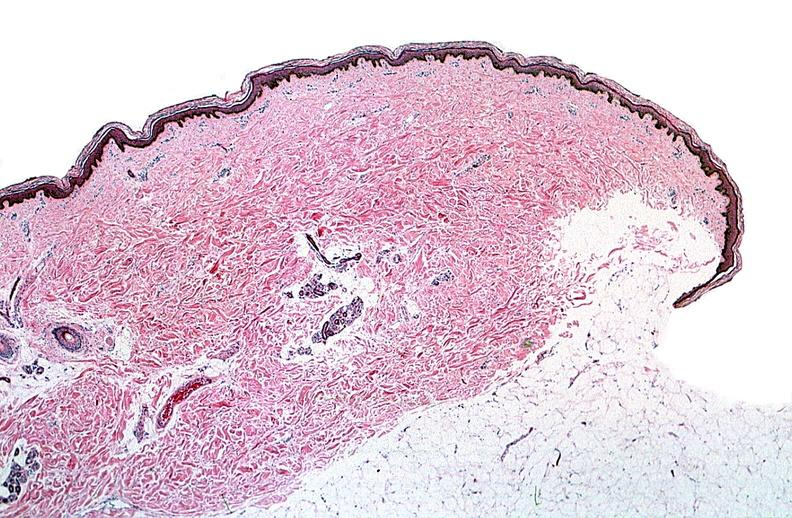where is this?
Answer the question using a single word or phrase. Skin 